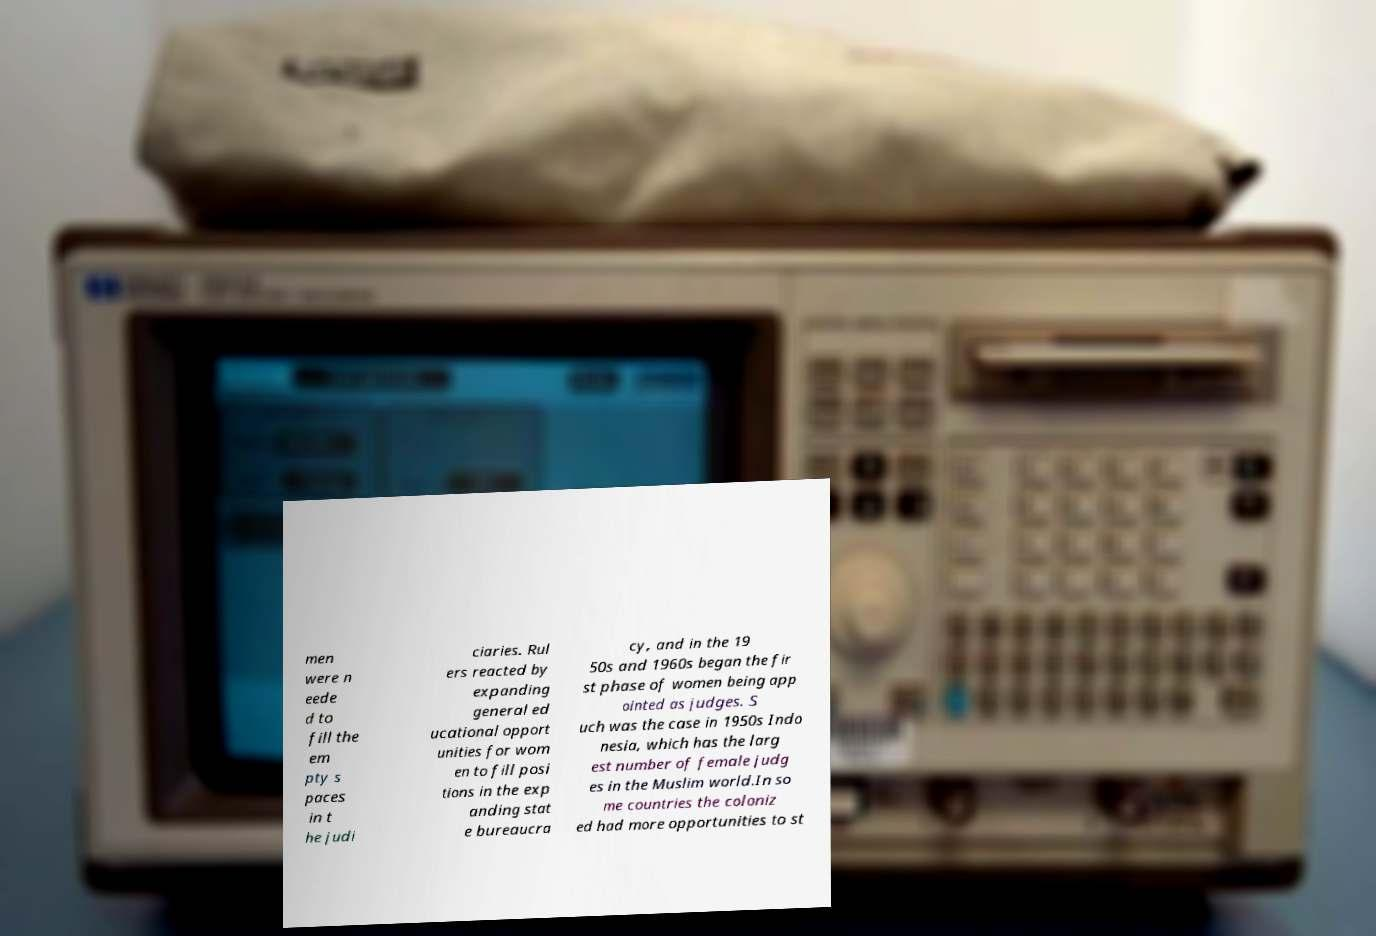What messages or text are displayed in this image? I need them in a readable, typed format. men were n eede d to fill the em pty s paces in t he judi ciaries. Rul ers reacted by expanding general ed ucational opport unities for wom en to fill posi tions in the exp anding stat e bureaucra cy, and in the 19 50s and 1960s began the fir st phase of women being app ointed as judges. S uch was the case in 1950s Indo nesia, which has the larg est number of female judg es in the Muslim world.In so me countries the coloniz ed had more opportunities to st 